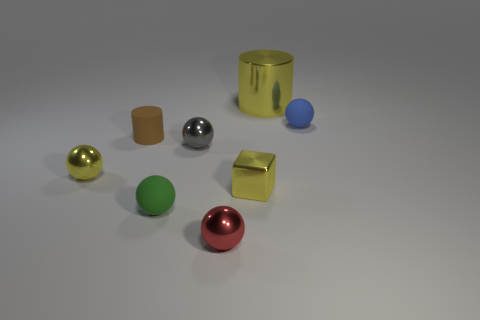Subtract all yellow spheres. How many spheres are left? 4 Subtract 1 balls. How many balls are left? 4 Subtract all small blue balls. How many balls are left? 4 Subtract all cyan balls. Subtract all green cylinders. How many balls are left? 5 Add 2 small brown blocks. How many objects exist? 10 Subtract all spheres. How many objects are left? 3 Subtract 1 brown cylinders. How many objects are left? 7 Subtract all blue metallic blocks. Subtract all tiny rubber things. How many objects are left? 5 Add 3 gray shiny balls. How many gray shiny balls are left? 4 Add 4 small purple matte blocks. How many small purple matte blocks exist? 4 